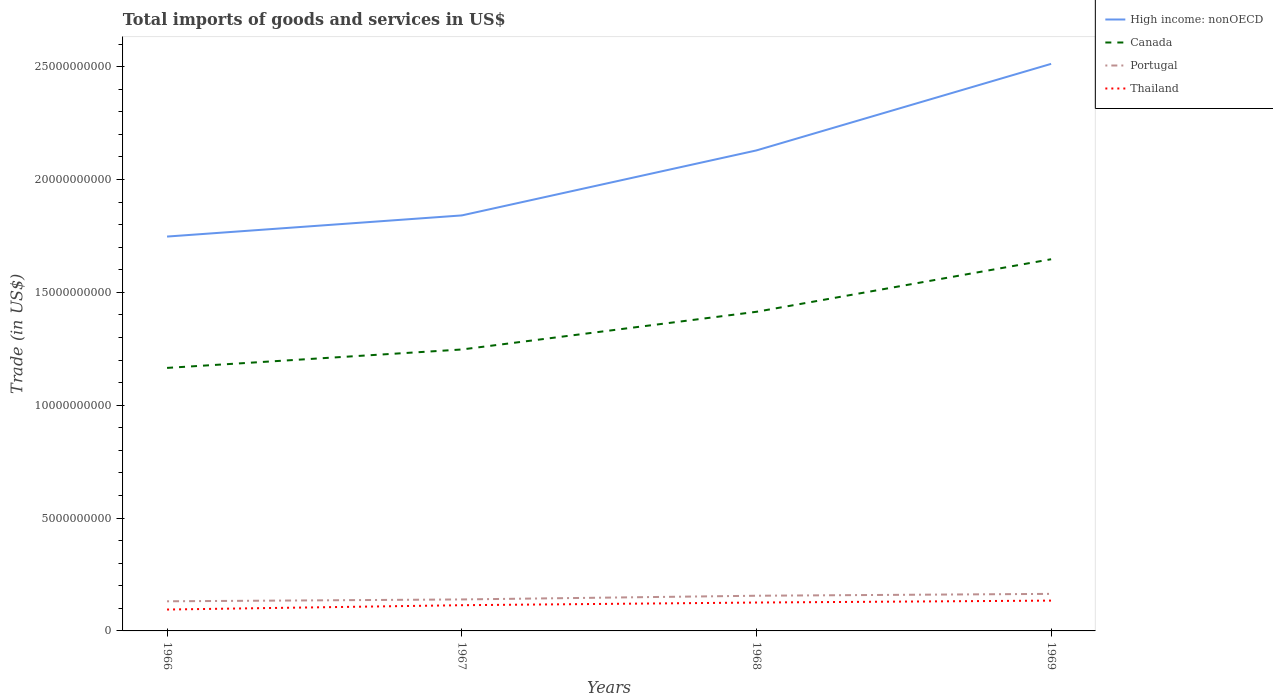Does the line corresponding to Portugal intersect with the line corresponding to High income: nonOECD?
Offer a very short reply. No. Across all years, what is the maximum total imports of goods and services in Portugal?
Provide a succinct answer. 1.31e+09. In which year was the total imports of goods and services in Portugal maximum?
Make the answer very short. 1966. What is the total total imports of goods and services in Canada in the graph?
Offer a very short reply. -2.49e+09. What is the difference between the highest and the second highest total imports of goods and services in High income: nonOECD?
Your answer should be compact. 7.65e+09. How many lines are there?
Give a very brief answer. 4. How many years are there in the graph?
Give a very brief answer. 4. Does the graph contain any zero values?
Make the answer very short. No. What is the title of the graph?
Make the answer very short. Total imports of goods and services in US$. Does "Serbia" appear as one of the legend labels in the graph?
Make the answer very short. No. What is the label or title of the X-axis?
Give a very brief answer. Years. What is the label or title of the Y-axis?
Keep it short and to the point. Trade (in US$). What is the Trade (in US$) of High income: nonOECD in 1966?
Give a very brief answer. 1.75e+1. What is the Trade (in US$) of Canada in 1966?
Ensure brevity in your answer.  1.17e+1. What is the Trade (in US$) in Portugal in 1966?
Your response must be concise. 1.31e+09. What is the Trade (in US$) of Thailand in 1966?
Provide a short and direct response. 9.47e+08. What is the Trade (in US$) of High income: nonOECD in 1967?
Offer a terse response. 1.84e+1. What is the Trade (in US$) in Canada in 1967?
Offer a very short reply. 1.25e+1. What is the Trade (in US$) of Portugal in 1967?
Provide a succinct answer. 1.39e+09. What is the Trade (in US$) in Thailand in 1967?
Your response must be concise. 1.14e+09. What is the Trade (in US$) in High income: nonOECD in 1968?
Provide a short and direct response. 2.13e+1. What is the Trade (in US$) of Canada in 1968?
Provide a succinct answer. 1.41e+1. What is the Trade (in US$) in Portugal in 1968?
Offer a terse response. 1.56e+09. What is the Trade (in US$) of Thailand in 1968?
Your answer should be very brief. 1.26e+09. What is the Trade (in US$) of High income: nonOECD in 1969?
Your answer should be compact. 2.51e+1. What is the Trade (in US$) in Canada in 1969?
Make the answer very short. 1.65e+1. What is the Trade (in US$) in Portugal in 1969?
Your response must be concise. 1.64e+09. What is the Trade (in US$) of Thailand in 1969?
Your answer should be very brief. 1.34e+09. Across all years, what is the maximum Trade (in US$) in High income: nonOECD?
Keep it short and to the point. 2.51e+1. Across all years, what is the maximum Trade (in US$) of Canada?
Provide a short and direct response. 1.65e+1. Across all years, what is the maximum Trade (in US$) of Portugal?
Provide a succinct answer. 1.64e+09. Across all years, what is the maximum Trade (in US$) of Thailand?
Provide a short and direct response. 1.34e+09. Across all years, what is the minimum Trade (in US$) of High income: nonOECD?
Provide a short and direct response. 1.75e+1. Across all years, what is the minimum Trade (in US$) in Canada?
Keep it short and to the point. 1.17e+1. Across all years, what is the minimum Trade (in US$) in Portugal?
Provide a succinct answer. 1.31e+09. Across all years, what is the minimum Trade (in US$) of Thailand?
Your response must be concise. 9.47e+08. What is the total Trade (in US$) in High income: nonOECD in the graph?
Your answer should be very brief. 8.23e+1. What is the total Trade (in US$) of Canada in the graph?
Provide a succinct answer. 5.47e+1. What is the total Trade (in US$) of Portugal in the graph?
Make the answer very short. 5.91e+09. What is the total Trade (in US$) in Thailand in the graph?
Offer a very short reply. 4.69e+09. What is the difference between the Trade (in US$) of High income: nonOECD in 1966 and that in 1967?
Make the answer very short. -9.37e+08. What is the difference between the Trade (in US$) of Canada in 1966 and that in 1967?
Offer a very short reply. -8.17e+08. What is the difference between the Trade (in US$) in Portugal in 1966 and that in 1967?
Your answer should be compact. -8.21e+07. What is the difference between the Trade (in US$) of Thailand in 1966 and that in 1967?
Give a very brief answer. -1.92e+08. What is the difference between the Trade (in US$) in High income: nonOECD in 1966 and that in 1968?
Make the answer very short. -3.82e+09. What is the difference between the Trade (in US$) in Canada in 1966 and that in 1968?
Provide a succinct answer. -2.49e+09. What is the difference between the Trade (in US$) of Portugal in 1966 and that in 1968?
Ensure brevity in your answer.  -2.46e+08. What is the difference between the Trade (in US$) in Thailand in 1966 and that in 1968?
Your answer should be compact. -3.10e+08. What is the difference between the Trade (in US$) in High income: nonOECD in 1966 and that in 1969?
Your answer should be very brief. -7.65e+09. What is the difference between the Trade (in US$) of Canada in 1966 and that in 1969?
Offer a very short reply. -4.81e+09. What is the difference between the Trade (in US$) in Portugal in 1966 and that in 1969?
Your response must be concise. -3.29e+08. What is the difference between the Trade (in US$) of Thailand in 1966 and that in 1969?
Provide a succinct answer. -3.96e+08. What is the difference between the Trade (in US$) of High income: nonOECD in 1967 and that in 1968?
Make the answer very short. -2.88e+09. What is the difference between the Trade (in US$) in Canada in 1967 and that in 1968?
Offer a very short reply. -1.67e+09. What is the difference between the Trade (in US$) in Portugal in 1967 and that in 1968?
Your response must be concise. -1.64e+08. What is the difference between the Trade (in US$) of Thailand in 1967 and that in 1968?
Your answer should be very brief. -1.18e+08. What is the difference between the Trade (in US$) in High income: nonOECD in 1967 and that in 1969?
Keep it short and to the point. -6.72e+09. What is the difference between the Trade (in US$) of Canada in 1967 and that in 1969?
Offer a very short reply. -4.00e+09. What is the difference between the Trade (in US$) of Portugal in 1967 and that in 1969?
Give a very brief answer. -2.47e+08. What is the difference between the Trade (in US$) of Thailand in 1967 and that in 1969?
Your response must be concise. -2.04e+08. What is the difference between the Trade (in US$) in High income: nonOECD in 1968 and that in 1969?
Your answer should be compact. -3.84e+09. What is the difference between the Trade (in US$) of Canada in 1968 and that in 1969?
Make the answer very short. -2.33e+09. What is the difference between the Trade (in US$) of Portugal in 1968 and that in 1969?
Offer a very short reply. -8.27e+07. What is the difference between the Trade (in US$) in Thailand in 1968 and that in 1969?
Give a very brief answer. -8.55e+07. What is the difference between the Trade (in US$) of High income: nonOECD in 1966 and the Trade (in US$) of Canada in 1967?
Your response must be concise. 5.00e+09. What is the difference between the Trade (in US$) of High income: nonOECD in 1966 and the Trade (in US$) of Portugal in 1967?
Your answer should be very brief. 1.61e+1. What is the difference between the Trade (in US$) of High income: nonOECD in 1966 and the Trade (in US$) of Thailand in 1967?
Your answer should be compact. 1.63e+1. What is the difference between the Trade (in US$) of Canada in 1966 and the Trade (in US$) of Portugal in 1967?
Ensure brevity in your answer.  1.03e+1. What is the difference between the Trade (in US$) in Canada in 1966 and the Trade (in US$) in Thailand in 1967?
Your response must be concise. 1.05e+1. What is the difference between the Trade (in US$) in Portugal in 1966 and the Trade (in US$) in Thailand in 1967?
Your answer should be very brief. 1.73e+08. What is the difference between the Trade (in US$) in High income: nonOECD in 1966 and the Trade (in US$) in Canada in 1968?
Offer a terse response. 3.33e+09. What is the difference between the Trade (in US$) of High income: nonOECD in 1966 and the Trade (in US$) of Portugal in 1968?
Your answer should be compact. 1.59e+1. What is the difference between the Trade (in US$) of High income: nonOECD in 1966 and the Trade (in US$) of Thailand in 1968?
Your answer should be compact. 1.62e+1. What is the difference between the Trade (in US$) in Canada in 1966 and the Trade (in US$) in Portugal in 1968?
Provide a short and direct response. 1.01e+1. What is the difference between the Trade (in US$) in Canada in 1966 and the Trade (in US$) in Thailand in 1968?
Offer a very short reply. 1.04e+1. What is the difference between the Trade (in US$) in Portugal in 1966 and the Trade (in US$) in Thailand in 1968?
Give a very brief answer. 5.51e+07. What is the difference between the Trade (in US$) in High income: nonOECD in 1966 and the Trade (in US$) in Canada in 1969?
Keep it short and to the point. 1.00e+09. What is the difference between the Trade (in US$) in High income: nonOECD in 1966 and the Trade (in US$) in Portugal in 1969?
Offer a very short reply. 1.58e+1. What is the difference between the Trade (in US$) of High income: nonOECD in 1966 and the Trade (in US$) of Thailand in 1969?
Give a very brief answer. 1.61e+1. What is the difference between the Trade (in US$) of Canada in 1966 and the Trade (in US$) of Portugal in 1969?
Your answer should be very brief. 1.00e+1. What is the difference between the Trade (in US$) of Canada in 1966 and the Trade (in US$) of Thailand in 1969?
Provide a short and direct response. 1.03e+1. What is the difference between the Trade (in US$) in Portugal in 1966 and the Trade (in US$) in Thailand in 1969?
Give a very brief answer. -3.04e+07. What is the difference between the Trade (in US$) of High income: nonOECD in 1967 and the Trade (in US$) of Canada in 1968?
Offer a very short reply. 4.27e+09. What is the difference between the Trade (in US$) in High income: nonOECD in 1967 and the Trade (in US$) in Portugal in 1968?
Offer a very short reply. 1.69e+1. What is the difference between the Trade (in US$) of High income: nonOECD in 1967 and the Trade (in US$) of Thailand in 1968?
Offer a terse response. 1.72e+1. What is the difference between the Trade (in US$) in Canada in 1967 and the Trade (in US$) in Portugal in 1968?
Make the answer very short. 1.09e+1. What is the difference between the Trade (in US$) in Canada in 1967 and the Trade (in US$) in Thailand in 1968?
Give a very brief answer. 1.12e+1. What is the difference between the Trade (in US$) of Portugal in 1967 and the Trade (in US$) of Thailand in 1968?
Your answer should be compact. 1.37e+08. What is the difference between the Trade (in US$) of High income: nonOECD in 1967 and the Trade (in US$) of Canada in 1969?
Offer a very short reply. 1.94e+09. What is the difference between the Trade (in US$) in High income: nonOECD in 1967 and the Trade (in US$) in Portugal in 1969?
Keep it short and to the point. 1.68e+1. What is the difference between the Trade (in US$) of High income: nonOECD in 1967 and the Trade (in US$) of Thailand in 1969?
Your response must be concise. 1.71e+1. What is the difference between the Trade (in US$) of Canada in 1967 and the Trade (in US$) of Portugal in 1969?
Give a very brief answer. 1.08e+1. What is the difference between the Trade (in US$) of Canada in 1967 and the Trade (in US$) of Thailand in 1969?
Offer a terse response. 1.11e+1. What is the difference between the Trade (in US$) in Portugal in 1967 and the Trade (in US$) in Thailand in 1969?
Ensure brevity in your answer.  5.17e+07. What is the difference between the Trade (in US$) of High income: nonOECD in 1968 and the Trade (in US$) of Canada in 1969?
Ensure brevity in your answer.  4.82e+09. What is the difference between the Trade (in US$) of High income: nonOECD in 1968 and the Trade (in US$) of Portugal in 1969?
Ensure brevity in your answer.  1.96e+1. What is the difference between the Trade (in US$) of High income: nonOECD in 1968 and the Trade (in US$) of Thailand in 1969?
Make the answer very short. 1.99e+1. What is the difference between the Trade (in US$) of Canada in 1968 and the Trade (in US$) of Portugal in 1969?
Keep it short and to the point. 1.25e+1. What is the difference between the Trade (in US$) of Canada in 1968 and the Trade (in US$) of Thailand in 1969?
Offer a terse response. 1.28e+1. What is the difference between the Trade (in US$) in Portugal in 1968 and the Trade (in US$) in Thailand in 1969?
Make the answer very short. 2.16e+08. What is the average Trade (in US$) in High income: nonOECD per year?
Provide a succinct answer. 2.06e+1. What is the average Trade (in US$) of Canada per year?
Your answer should be compact. 1.37e+1. What is the average Trade (in US$) of Portugal per year?
Your answer should be very brief. 1.48e+09. What is the average Trade (in US$) of Thailand per year?
Ensure brevity in your answer.  1.17e+09. In the year 1966, what is the difference between the Trade (in US$) of High income: nonOECD and Trade (in US$) of Canada?
Provide a succinct answer. 5.82e+09. In the year 1966, what is the difference between the Trade (in US$) in High income: nonOECD and Trade (in US$) in Portugal?
Provide a succinct answer. 1.62e+1. In the year 1966, what is the difference between the Trade (in US$) in High income: nonOECD and Trade (in US$) in Thailand?
Provide a short and direct response. 1.65e+1. In the year 1966, what is the difference between the Trade (in US$) of Canada and Trade (in US$) of Portugal?
Offer a very short reply. 1.03e+1. In the year 1966, what is the difference between the Trade (in US$) in Canada and Trade (in US$) in Thailand?
Provide a short and direct response. 1.07e+1. In the year 1966, what is the difference between the Trade (in US$) in Portugal and Trade (in US$) in Thailand?
Ensure brevity in your answer.  3.65e+08. In the year 1967, what is the difference between the Trade (in US$) in High income: nonOECD and Trade (in US$) in Canada?
Make the answer very short. 5.94e+09. In the year 1967, what is the difference between the Trade (in US$) of High income: nonOECD and Trade (in US$) of Portugal?
Keep it short and to the point. 1.70e+1. In the year 1967, what is the difference between the Trade (in US$) of High income: nonOECD and Trade (in US$) of Thailand?
Provide a succinct answer. 1.73e+1. In the year 1967, what is the difference between the Trade (in US$) in Canada and Trade (in US$) in Portugal?
Provide a succinct answer. 1.11e+1. In the year 1967, what is the difference between the Trade (in US$) of Canada and Trade (in US$) of Thailand?
Give a very brief answer. 1.13e+1. In the year 1967, what is the difference between the Trade (in US$) of Portugal and Trade (in US$) of Thailand?
Ensure brevity in your answer.  2.55e+08. In the year 1968, what is the difference between the Trade (in US$) of High income: nonOECD and Trade (in US$) of Canada?
Make the answer very short. 7.15e+09. In the year 1968, what is the difference between the Trade (in US$) in High income: nonOECD and Trade (in US$) in Portugal?
Offer a terse response. 1.97e+1. In the year 1968, what is the difference between the Trade (in US$) in High income: nonOECD and Trade (in US$) in Thailand?
Your answer should be compact. 2.00e+1. In the year 1968, what is the difference between the Trade (in US$) of Canada and Trade (in US$) of Portugal?
Provide a short and direct response. 1.26e+1. In the year 1968, what is the difference between the Trade (in US$) in Canada and Trade (in US$) in Thailand?
Provide a succinct answer. 1.29e+1. In the year 1968, what is the difference between the Trade (in US$) of Portugal and Trade (in US$) of Thailand?
Offer a very short reply. 3.01e+08. In the year 1969, what is the difference between the Trade (in US$) of High income: nonOECD and Trade (in US$) of Canada?
Provide a succinct answer. 8.66e+09. In the year 1969, what is the difference between the Trade (in US$) in High income: nonOECD and Trade (in US$) in Portugal?
Your answer should be compact. 2.35e+1. In the year 1969, what is the difference between the Trade (in US$) of High income: nonOECD and Trade (in US$) of Thailand?
Keep it short and to the point. 2.38e+1. In the year 1969, what is the difference between the Trade (in US$) of Canada and Trade (in US$) of Portugal?
Make the answer very short. 1.48e+1. In the year 1969, what is the difference between the Trade (in US$) of Canada and Trade (in US$) of Thailand?
Your response must be concise. 1.51e+1. In the year 1969, what is the difference between the Trade (in US$) of Portugal and Trade (in US$) of Thailand?
Make the answer very short. 2.99e+08. What is the ratio of the Trade (in US$) of High income: nonOECD in 1966 to that in 1967?
Give a very brief answer. 0.95. What is the ratio of the Trade (in US$) of Canada in 1966 to that in 1967?
Your answer should be very brief. 0.93. What is the ratio of the Trade (in US$) of Portugal in 1966 to that in 1967?
Make the answer very short. 0.94. What is the ratio of the Trade (in US$) in Thailand in 1966 to that in 1967?
Make the answer very short. 0.83. What is the ratio of the Trade (in US$) in High income: nonOECD in 1966 to that in 1968?
Offer a terse response. 0.82. What is the ratio of the Trade (in US$) of Canada in 1966 to that in 1968?
Give a very brief answer. 0.82. What is the ratio of the Trade (in US$) in Portugal in 1966 to that in 1968?
Provide a succinct answer. 0.84. What is the ratio of the Trade (in US$) of Thailand in 1966 to that in 1968?
Provide a succinct answer. 0.75. What is the ratio of the Trade (in US$) of High income: nonOECD in 1966 to that in 1969?
Provide a short and direct response. 0.7. What is the ratio of the Trade (in US$) in Canada in 1966 to that in 1969?
Provide a short and direct response. 0.71. What is the ratio of the Trade (in US$) in Portugal in 1966 to that in 1969?
Your answer should be compact. 0.8. What is the ratio of the Trade (in US$) in Thailand in 1966 to that in 1969?
Your answer should be very brief. 0.71. What is the ratio of the Trade (in US$) in High income: nonOECD in 1967 to that in 1968?
Offer a very short reply. 0.86. What is the ratio of the Trade (in US$) of Canada in 1967 to that in 1968?
Give a very brief answer. 0.88. What is the ratio of the Trade (in US$) of Portugal in 1967 to that in 1968?
Your response must be concise. 0.89. What is the ratio of the Trade (in US$) in Thailand in 1967 to that in 1968?
Provide a short and direct response. 0.91. What is the ratio of the Trade (in US$) in High income: nonOECD in 1967 to that in 1969?
Offer a terse response. 0.73. What is the ratio of the Trade (in US$) in Canada in 1967 to that in 1969?
Offer a very short reply. 0.76. What is the ratio of the Trade (in US$) in Portugal in 1967 to that in 1969?
Provide a succinct answer. 0.85. What is the ratio of the Trade (in US$) in Thailand in 1967 to that in 1969?
Your response must be concise. 0.85. What is the ratio of the Trade (in US$) in High income: nonOECD in 1968 to that in 1969?
Ensure brevity in your answer.  0.85. What is the ratio of the Trade (in US$) in Canada in 1968 to that in 1969?
Your response must be concise. 0.86. What is the ratio of the Trade (in US$) of Portugal in 1968 to that in 1969?
Provide a short and direct response. 0.95. What is the ratio of the Trade (in US$) of Thailand in 1968 to that in 1969?
Provide a succinct answer. 0.94. What is the difference between the highest and the second highest Trade (in US$) in High income: nonOECD?
Offer a terse response. 3.84e+09. What is the difference between the highest and the second highest Trade (in US$) of Canada?
Keep it short and to the point. 2.33e+09. What is the difference between the highest and the second highest Trade (in US$) of Portugal?
Provide a succinct answer. 8.27e+07. What is the difference between the highest and the second highest Trade (in US$) in Thailand?
Your answer should be compact. 8.55e+07. What is the difference between the highest and the lowest Trade (in US$) of High income: nonOECD?
Ensure brevity in your answer.  7.65e+09. What is the difference between the highest and the lowest Trade (in US$) of Canada?
Ensure brevity in your answer.  4.81e+09. What is the difference between the highest and the lowest Trade (in US$) in Portugal?
Your answer should be compact. 3.29e+08. What is the difference between the highest and the lowest Trade (in US$) in Thailand?
Make the answer very short. 3.96e+08. 